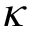<formula> <loc_0><loc_0><loc_500><loc_500>\kappa</formula> 